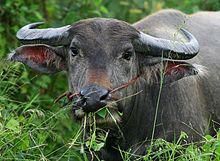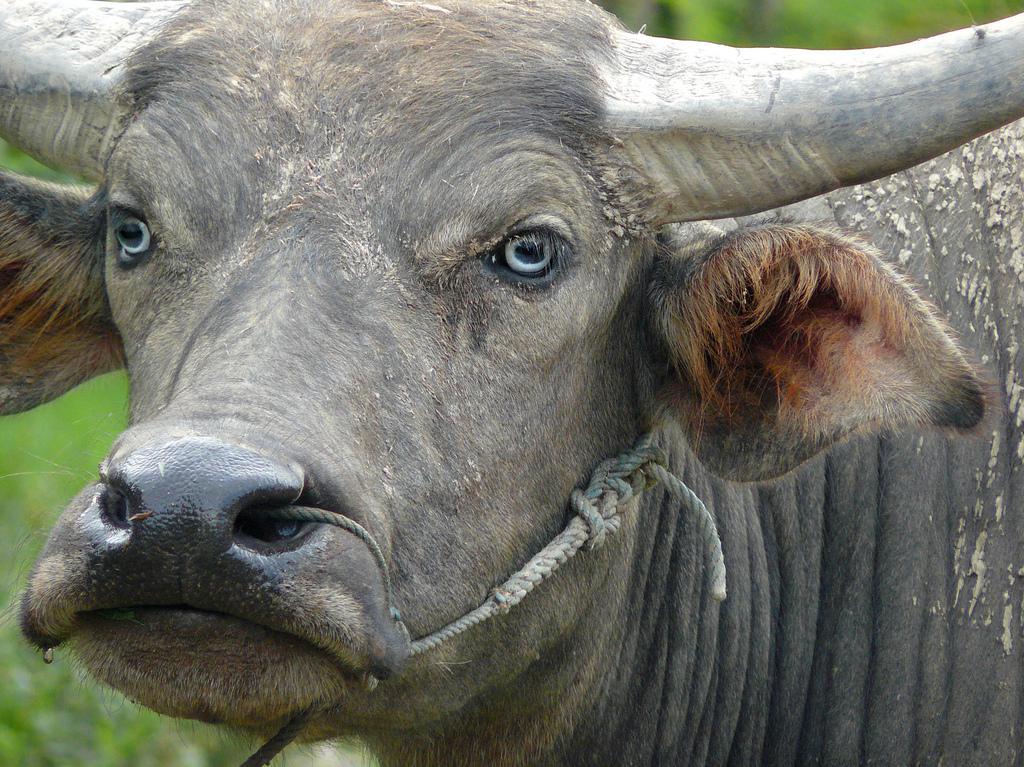The first image is the image on the left, the second image is the image on the right. Examine the images to the left and right. Is the description "There are two bison-like creatures only." accurate? Answer yes or no. Yes. 